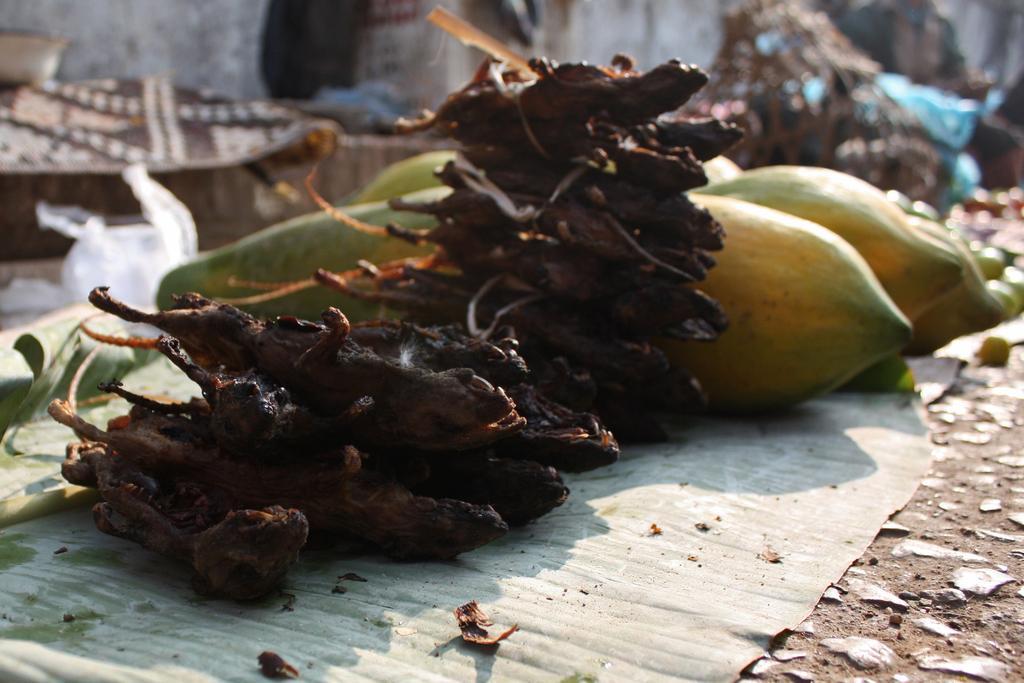Please provide a concise description of this image. In this image I can see a food on the banana leaf. Food is in yellow,green and brown color. Background is blurred. 